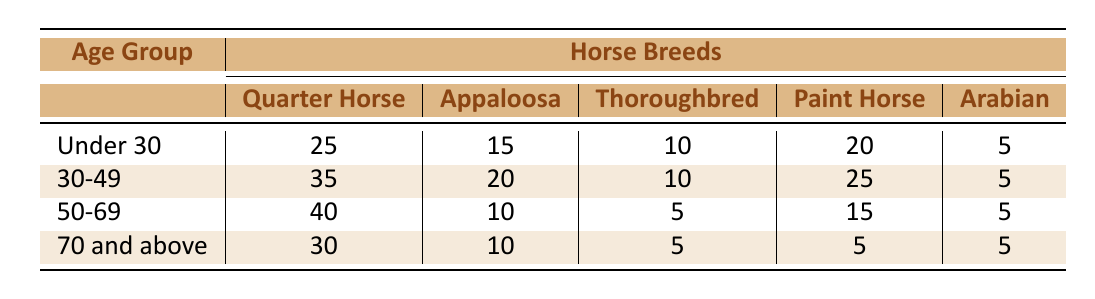What is the most popular horse breed among ranchers aged under 30? The highest number of horses for the age group under 30 is 25 for the Quarter Horse. By looking at the table, we can see that the value is higher than for any other breed in that age group.
Answer: Quarter Horse Which age group has the least number of Appaloosa horses? In the age groups, the one with the least number of Appaloosa horses is 50-69, with only 10 Appaloosas. This can be verified by checking all the age groups and identifying the lowest figure for that breed.
Answer: 50-69 How many more Quarter Horses do ranchers aged 30-49 have compared to ranchers aged 70 and above? For the 30-49 age group, there are 35 Quarter Horses, and for the 70 and above group, there are 30 Quarter Horses. To find the difference, we subtract the two values: 35 - 30 = 5. This shows how many more Quarter Horses are in the 30-49 age group compared to the 70 and above group.
Answer: 5 Is it true that the Thoroughbred is more popular among ranchers aged under 30 than among those aged 50-69? Yes, this statement holds true because under 30 shows 10 Thoroughbreds, whereas the 50-69 age group only has 5 Thoroughbreds. Comparing these two figures confirms that under 30 has more Thoroughbreds than 50-69.
Answer: Yes What is the average number of Arabian horses across all age groups? To find the average number of Arabian horses, we first list the values for all age groups: 5 (under 30) + 5 (30-49) + 5 (50-69) + 5 (70 and above) = 20. There are 4 age groups, so we divide the total by 4: 20 / 4 = 5. Therefore, the average number of Arabian horses is 5.
Answer: 5 Which horse breed has the highest popularity among ranchers aged 50-69? In the age group 50-69, the highest count is 40 for the Quarter Horse. This can be confirmed by looking across the row for that age group and identifying the highest number.
Answer: Quarter Horse 